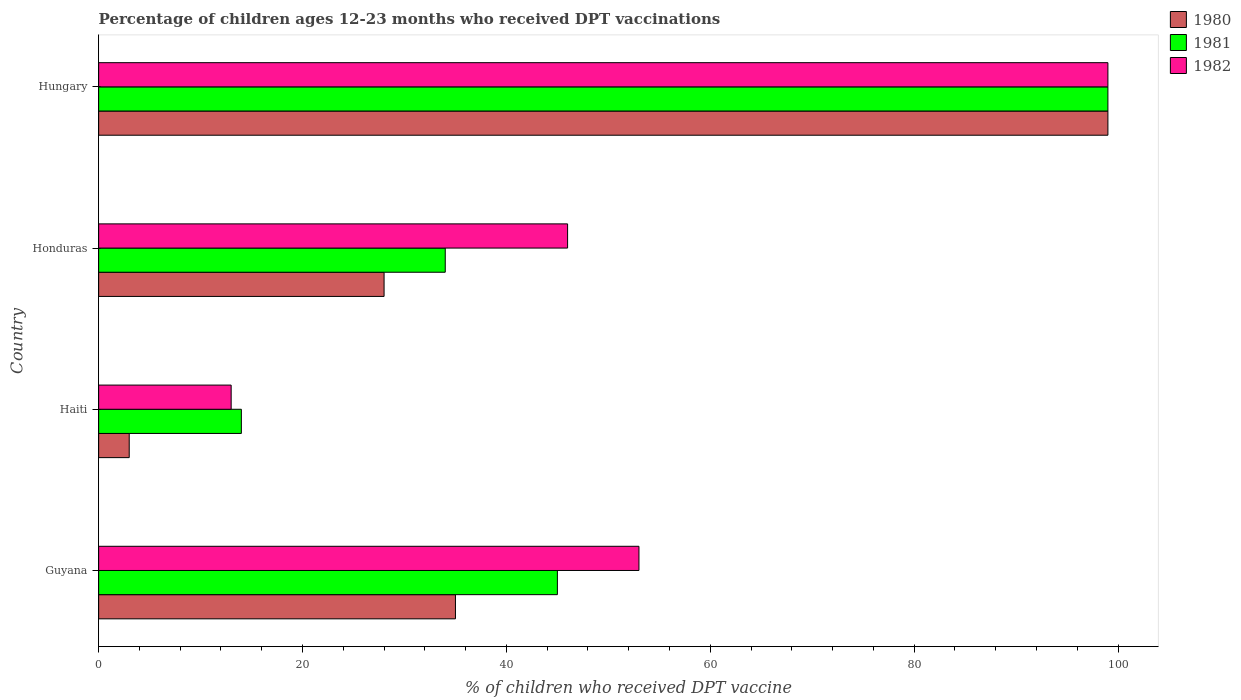Are the number of bars per tick equal to the number of legend labels?
Make the answer very short. Yes. What is the label of the 3rd group of bars from the top?
Provide a succinct answer. Haiti. In how many cases, is the number of bars for a given country not equal to the number of legend labels?
Provide a succinct answer. 0. What is the percentage of children who received DPT vaccination in 1980 in Honduras?
Give a very brief answer. 28. Across all countries, what is the maximum percentage of children who received DPT vaccination in 1981?
Give a very brief answer. 99. Across all countries, what is the minimum percentage of children who received DPT vaccination in 1981?
Provide a succinct answer. 14. In which country was the percentage of children who received DPT vaccination in 1981 maximum?
Your answer should be compact. Hungary. In which country was the percentage of children who received DPT vaccination in 1980 minimum?
Provide a succinct answer. Haiti. What is the total percentage of children who received DPT vaccination in 1982 in the graph?
Offer a terse response. 211. What is the difference between the percentage of children who received DPT vaccination in 1981 in Guyana and that in Hungary?
Your response must be concise. -54. What is the difference between the percentage of children who received DPT vaccination in 1980 in Honduras and the percentage of children who received DPT vaccination in 1982 in Hungary?
Your answer should be compact. -71. What is the average percentage of children who received DPT vaccination in 1982 per country?
Keep it short and to the point. 52.75. What is the difference between the percentage of children who received DPT vaccination in 1980 and percentage of children who received DPT vaccination in 1982 in Honduras?
Give a very brief answer. -18. In how many countries, is the percentage of children who received DPT vaccination in 1982 greater than 92 %?
Provide a succinct answer. 1. What is the ratio of the percentage of children who received DPT vaccination in 1982 in Haiti to that in Hungary?
Offer a terse response. 0.13. What is the difference between the highest and the second highest percentage of children who received DPT vaccination in 1981?
Ensure brevity in your answer.  54. In how many countries, is the percentage of children who received DPT vaccination in 1982 greater than the average percentage of children who received DPT vaccination in 1982 taken over all countries?
Your answer should be compact. 2. What does the 1st bar from the top in Honduras represents?
Keep it short and to the point. 1982. How many bars are there?
Provide a succinct answer. 12. Are all the bars in the graph horizontal?
Offer a terse response. Yes. How many countries are there in the graph?
Keep it short and to the point. 4. What is the difference between two consecutive major ticks on the X-axis?
Provide a succinct answer. 20. Where does the legend appear in the graph?
Ensure brevity in your answer.  Top right. How are the legend labels stacked?
Provide a succinct answer. Vertical. What is the title of the graph?
Your answer should be very brief. Percentage of children ages 12-23 months who received DPT vaccinations. What is the label or title of the X-axis?
Provide a succinct answer. % of children who received DPT vaccine. What is the label or title of the Y-axis?
Your answer should be very brief. Country. What is the % of children who received DPT vaccine in 1980 in Guyana?
Keep it short and to the point. 35. What is the % of children who received DPT vaccine in 1981 in Haiti?
Ensure brevity in your answer.  14. What is the % of children who received DPT vaccine of 1982 in Haiti?
Give a very brief answer. 13. What is the % of children who received DPT vaccine in 1981 in Honduras?
Offer a terse response. 34. Across all countries, what is the maximum % of children who received DPT vaccine in 1982?
Ensure brevity in your answer.  99. What is the total % of children who received DPT vaccine of 1980 in the graph?
Provide a succinct answer. 165. What is the total % of children who received DPT vaccine of 1981 in the graph?
Offer a very short reply. 192. What is the total % of children who received DPT vaccine in 1982 in the graph?
Your response must be concise. 211. What is the difference between the % of children who received DPT vaccine in 1980 in Guyana and that in Honduras?
Your response must be concise. 7. What is the difference between the % of children who received DPT vaccine in 1982 in Guyana and that in Honduras?
Keep it short and to the point. 7. What is the difference between the % of children who received DPT vaccine of 1980 in Guyana and that in Hungary?
Your answer should be very brief. -64. What is the difference between the % of children who received DPT vaccine of 1981 in Guyana and that in Hungary?
Your answer should be compact. -54. What is the difference between the % of children who received DPT vaccine in 1982 in Guyana and that in Hungary?
Keep it short and to the point. -46. What is the difference between the % of children who received DPT vaccine of 1980 in Haiti and that in Honduras?
Give a very brief answer. -25. What is the difference between the % of children who received DPT vaccine in 1981 in Haiti and that in Honduras?
Keep it short and to the point. -20. What is the difference between the % of children who received DPT vaccine in 1982 in Haiti and that in Honduras?
Keep it short and to the point. -33. What is the difference between the % of children who received DPT vaccine of 1980 in Haiti and that in Hungary?
Make the answer very short. -96. What is the difference between the % of children who received DPT vaccine of 1981 in Haiti and that in Hungary?
Offer a terse response. -85. What is the difference between the % of children who received DPT vaccine in 1982 in Haiti and that in Hungary?
Offer a terse response. -86. What is the difference between the % of children who received DPT vaccine in 1980 in Honduras and that in Hungary?
Give a very brief answer. -71. What is the difference between the % of children who received DPT vaccine in 1981 in Honduras and that in Hungary?
Ensure brevity in your answer.  -65. What is the difference between the % of children who received DPT vaccine in 1982 in Honduras and that in Hungary?
Make the answer very short. -53. What is the difference between the % of children who received DPT vaccine of 1980 in Guyana and the % of children who received DPT vaccine of 1982 in Haiti?
Your response must be concise. 22. What is the difference between the % of children who received DPT vaccine of 1980 in Guyana and the % of children who received DPT vaccine of 1981 in Honduras?
Keep it short and to the point. 1. What is the difference between the % of children who received DPT vaccine of 1980 in Guyana and the % of children who received DPT vaccine of 1982 in Honduras?
Keep it short and to the point. -11. What is the difference between the % of children who received DPT vaccine in 1981 in Guyana and the % of children who received DPT vaccine in 1982 in Honduras?
Provide a succinct answer. -1. What is the difference between the % of children who received DPT vaccine in 1980 in Guyana and the % of children who received DPT vaccine in 1981 in Hungary?
Offer a very short reply. -64. What is the difference between the % of children who received DPT vaccine in 1980 in Guyana and the % of children who received DPT vaccine in 1982 in Hungary?
Ensure brevity in your answer.  -64. What is the difference between the % of children who received DPT vaccine of 1981 in Guyana and the % of children who received DPT vaccine of 1982 in Hungary?
Your answer should be compact. -54. What is the difference between the % of children who received DPT vaccine of 1980 in Haiti and the % of children who received DPT vaccine of 1981 in Honduras?
Offer a terse response. -31. What is the difference between the % of children who received DPT vaccine in 1980 in Haiti and the % of children who received DPT vaccine in 1982 in Honduras?
Your answer should be very brief. -43. What is the difference between the % of children who received DPT vaccine in 1981 in Haiti and the % of children who received DPT vaccine in 1982 in Honduras?
Make the answer very short. -32. What is the difference between the % of children who received DPT vaccine of 1980 in Haiti and the % of children who received DPT vaccine of 1981 in Hungary?
Keep it short and to the point. -96. What is the difference between the % of children who received DPT vaccine of 1980 in Haiti and the % of children who received DPT vaccine of 1982 in Hungary?
Keep it short and to the point. -96. What is the difference between the % of children who received DPT vaccine in 1981 in Haiti and the % of children who received DPT vaccine in 1982 in Hungary?
Keep it short and to the point. -85. What is the difference between the % of children who received DPT vaccine in 1980 in Honduras and the % of children who received DPT vaccine in 1981 in Hungary?
Your answer should be compact. -71. What is the difference between the % of children who received DPT vaccine in 1980 in Honduras and the % of children who received DPT vaccine in 1982 in Hungary?
Keep it short and to the point. -71. What is the difference between the % of children who received DPT vaccine of 1981 in Honduras and the % of children who received DPT vaccine of 1982 in Hungary?
Provide a succinct answer. -65. What is the average % of children who received DPT vaccine of 1980 per country?
Provide a succinct answer. 41.25. What is the average % of children who received DPT vaccine of 1981 per country?
Your answer should be very brief. 48. What is the average % of children who received DPT vaccine in 1982 per country?
Ensure brevity in your answer.  52.75. What is the difference between the % of children who received DPT vaccine in 1980 and % of children who received DPT vaccine in 1982 in Guyana?
Your answer should be compact. -18. What is the difference between the % of children who received DPT vaccine of 1980 and % of children who received DPT vaccine of 1982 in Haiti?
Offer a terse response. -10. What is the difference between the % of children who received DPT vaccine in 1981 and % of children who received DPT vaccine in 1982 in Haiti?
Your answer should be very brief. 1. What is the difference between the % of children who received DPT vaccine in 1980 and % of children who received DPT vaccine in 1981 in Hungary?
Give a very brief answer. 0. What is the difference between the % of children who received DPT vaccine in 1980 and % of children who received DPT vaccine in 1982 in Hungary?
Provide a short and direct response. 0. What is the ratio of the % of children who received DPT vaccine in 1980 in Guyana to that in Haiti?
Your answer should be very brief. 11.67. What is the ratio of the % of children who received DPT vaccine of 1981 in Guyana to that in Haiti?
Your response must be concise. 3.21. What is the ratio of the % of children who received DPT vaccine of 1982 in Guyana to that in Haiti?
Offer a terse response. 4.08. What is the ratio of the % of children who received DPT vaccine of 1980 in Guyana to that in Honduras?
Provide a short and direct response. 1.25. What is the ratio of the % of children who received DPT vaccine in 1981 in Guyana to that in Honduras?
Give a very brief answer. 1.32. What is the ratio of the % of children who received DPT vaccine in 1982 in Guyana to that in Honduras?
Provide a succinct answer. 1.15. What is the ratio of the % of children who received DPT vaccine in 1980 in Guyana to that in Hungary?
Your response must be concise. 0.35. What is the ratio of the % of children who received DPT vaccine in 1981 in Guyana to that in Hungary?
Ensure brevity in your answer.  0.45. What is the ratio of the % of children who received DPT vaccine of 1982 in Guyana to that in Hungary?
Your response must be concise. 0.54. What is the ratio of the % of children who received DPT vaccine of 1980 in Haiti to that in Honduras?
Your answer should be compact. 0.11. What is the ratio of the % of children who received DPT vaccine in 1981 in Haiti to that in Honduras?
Offer a terse response. 0.41. What is the ratio of the % of children who received DPT vaccine of 1982 in Haiti to that in Honduras?
Your response must be concise. 0.28. What is the ratio of the % of children who received DPT vaccine of 1980 in Haiti to that in Hungary?
Your answer should be very brief. 0.03. What is the ratio of the % of children who received DPT vaccine in 1981 in Haiti to that in Hungary?
Make the answer very short. 0.14. What is the ratio of the % of children who received DPT vaccine in 1982 in Haiti to that in Hungary?
Offer a terse response. 0.13. What is the ratio of the % of children who received DPT vaccine of 1980 in Honduras to that in Hungary?
Provide a succinct answer. 0.28. What is the ratio of the % of children who received DPT vaccine of 1981 in Honduras to that in Hungary?
Your answer should be very brief. 0.34. What is the ratio of the % of children who received DPT vaccine in 1982 in Honduras to that in Hungary?
Provide a succinct answer. 0.46. What is the difference between the highest and the second highest % of children who received DPT vaccine in 1982?
Provide a succinct answer. 46. What is the difference between the highest and the lowest % of children who received DPT vaccine of 1980?
Your response must be concise. 96. What is the difference between the highest and the lowest % of children who received DPT vaccine of 1982?
Ensure brevity in your answer.  86. 